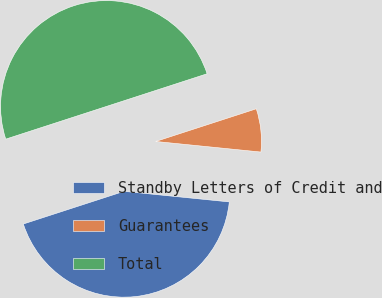<chart> <loc_0><loc_0><loc_500><loc_500><pie_chart><fcel>Standby Letters of Credit and<fcel>Guarantees<fcel>Total<nl><fcel>43.41%<fcel>6.59%<fcel>50.0%<nl></chart> 